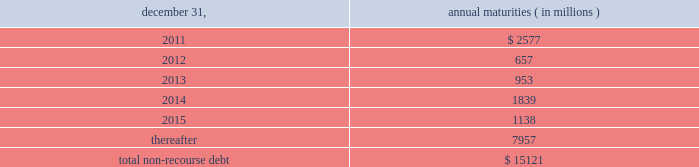The aes corporation notes to consolidated financial statements 2014 ( continued ) december 31 , 2010 , 2009 , and 2008 ( 3 ) multilateral loans include loans funded and guaranteed by bilaterals , multilaterals , development banks and other similar institutions .
( 4 ) non-recourse debt of $ 708 million as of december 31 , 2009 was excluded from non-recourse debt and included in current and long-term liabilities of held for sale and discontinued businesses in the accompanying consolidated balance sheets .
Non-recourse debt as of december 31 , 2010 is scheduled to reach maturity as set forth in the table below : december 31 , annual maturities ( in millions ) .
As of december 31 , 2010 , aes subsidiaries with facilities under construction had a total of approximately $ 432 million of committed but unused credit facilities available to fund construction and other related costs .
Excluding these facilities under construction , aes subsidiaries had approximately $ 893 million in a number of available but unused committed revolving credit lines to support their working capital , debt service reserves and other business needs .
These credit lines can be used in one or more of the following ways : solely for borrowings ; solely for letters of credit ; or a combination of these uses .
The weighted average interest rate on borrowings from these facilities was 3.24% ( 3.24 % ) at december 31 , 2010 .
Non-recourse debt covenants , restrictions and defaults the terms of the company 2019s non-recourse debt include certain financial and non-financial covenants .
These covenants are limited to subsidiary activity and vary among the subsidiaries .
These covenants may include but are not limited to maintenance of certain reserves , minimum levels of working capital and limitations on incurring additional indebtedness .
Compliance with certain covenants may not be objectively determinable .
As of december 31 , 2010 and 2009 , approximately $ 803 million and $ 653 million , respectively , of restricted cash was maintained in accordance with certain covenants of the non-recourse debt agreements , and these amounts were included within 201crestricted cash 201d and 201cdebt service reserves and other deposits 201d in the accompanying consolidated balance sheets .
Various lender and governmental provisions restrict the ability of certain of the company 2019s subsidiaries to transfer their net assets to the parent company .
Such restricted net assets of subsidiaries amounted to approximately $ 5.4 billion at december 31 , 2010. .
As of december 31 , 2010 , what was the total committed but unused credit facilities in millions? 
Computations: (432 + 893)
Answer: 1325.0. 